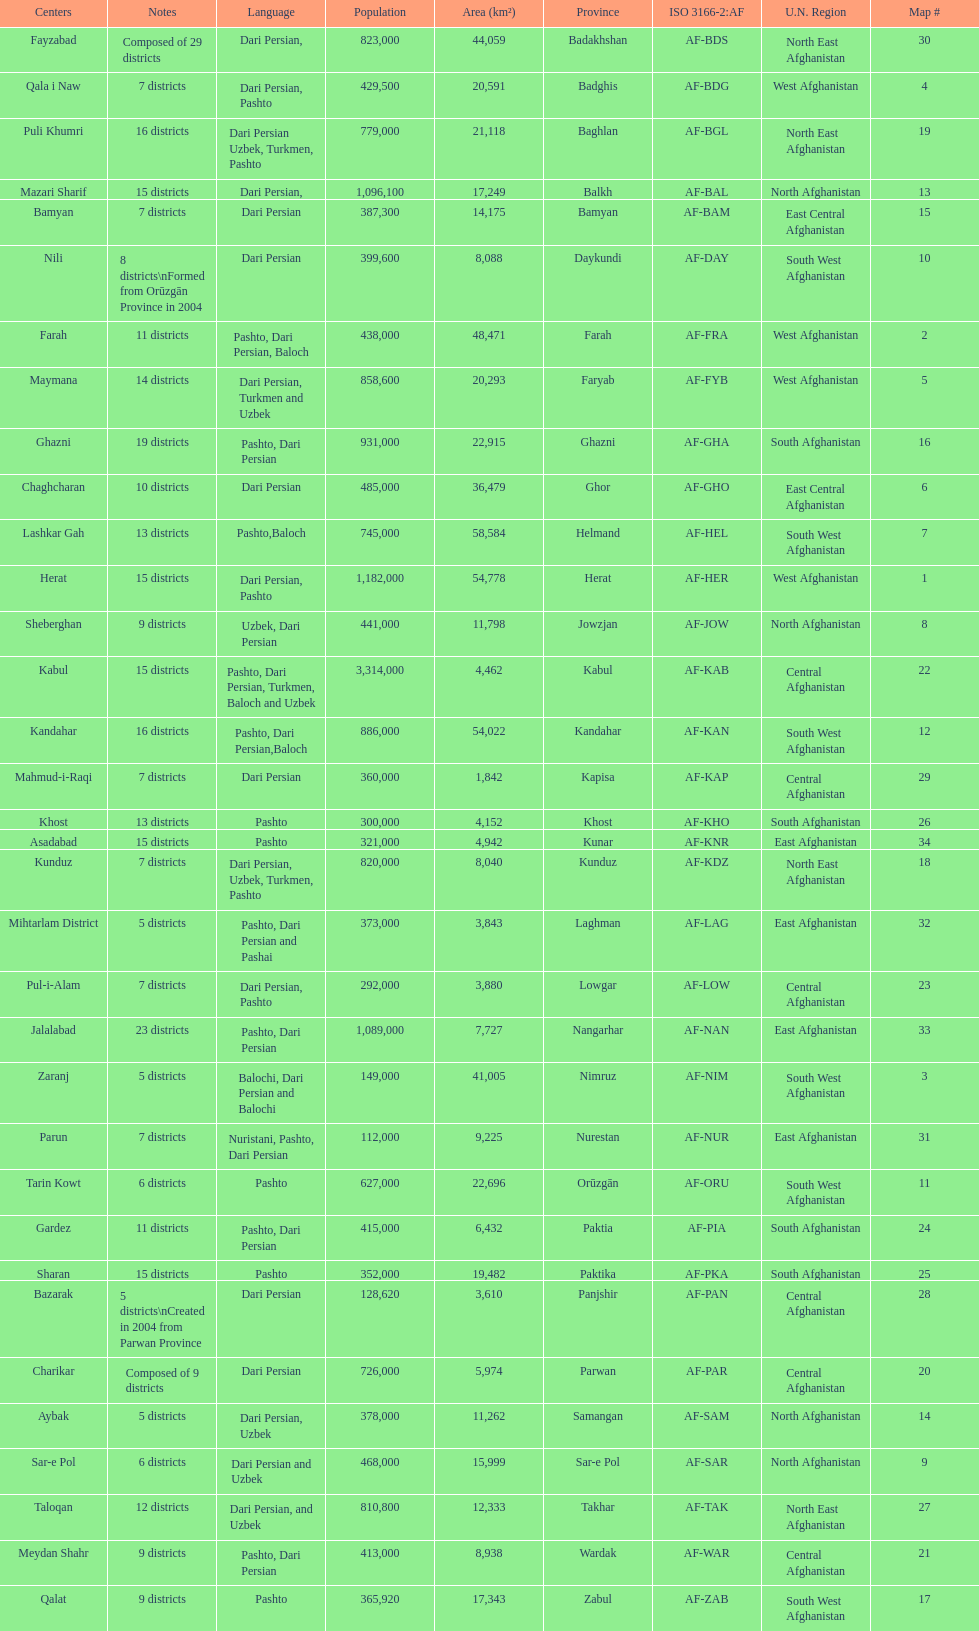How many provinces have pashto as one of their languages 20. 